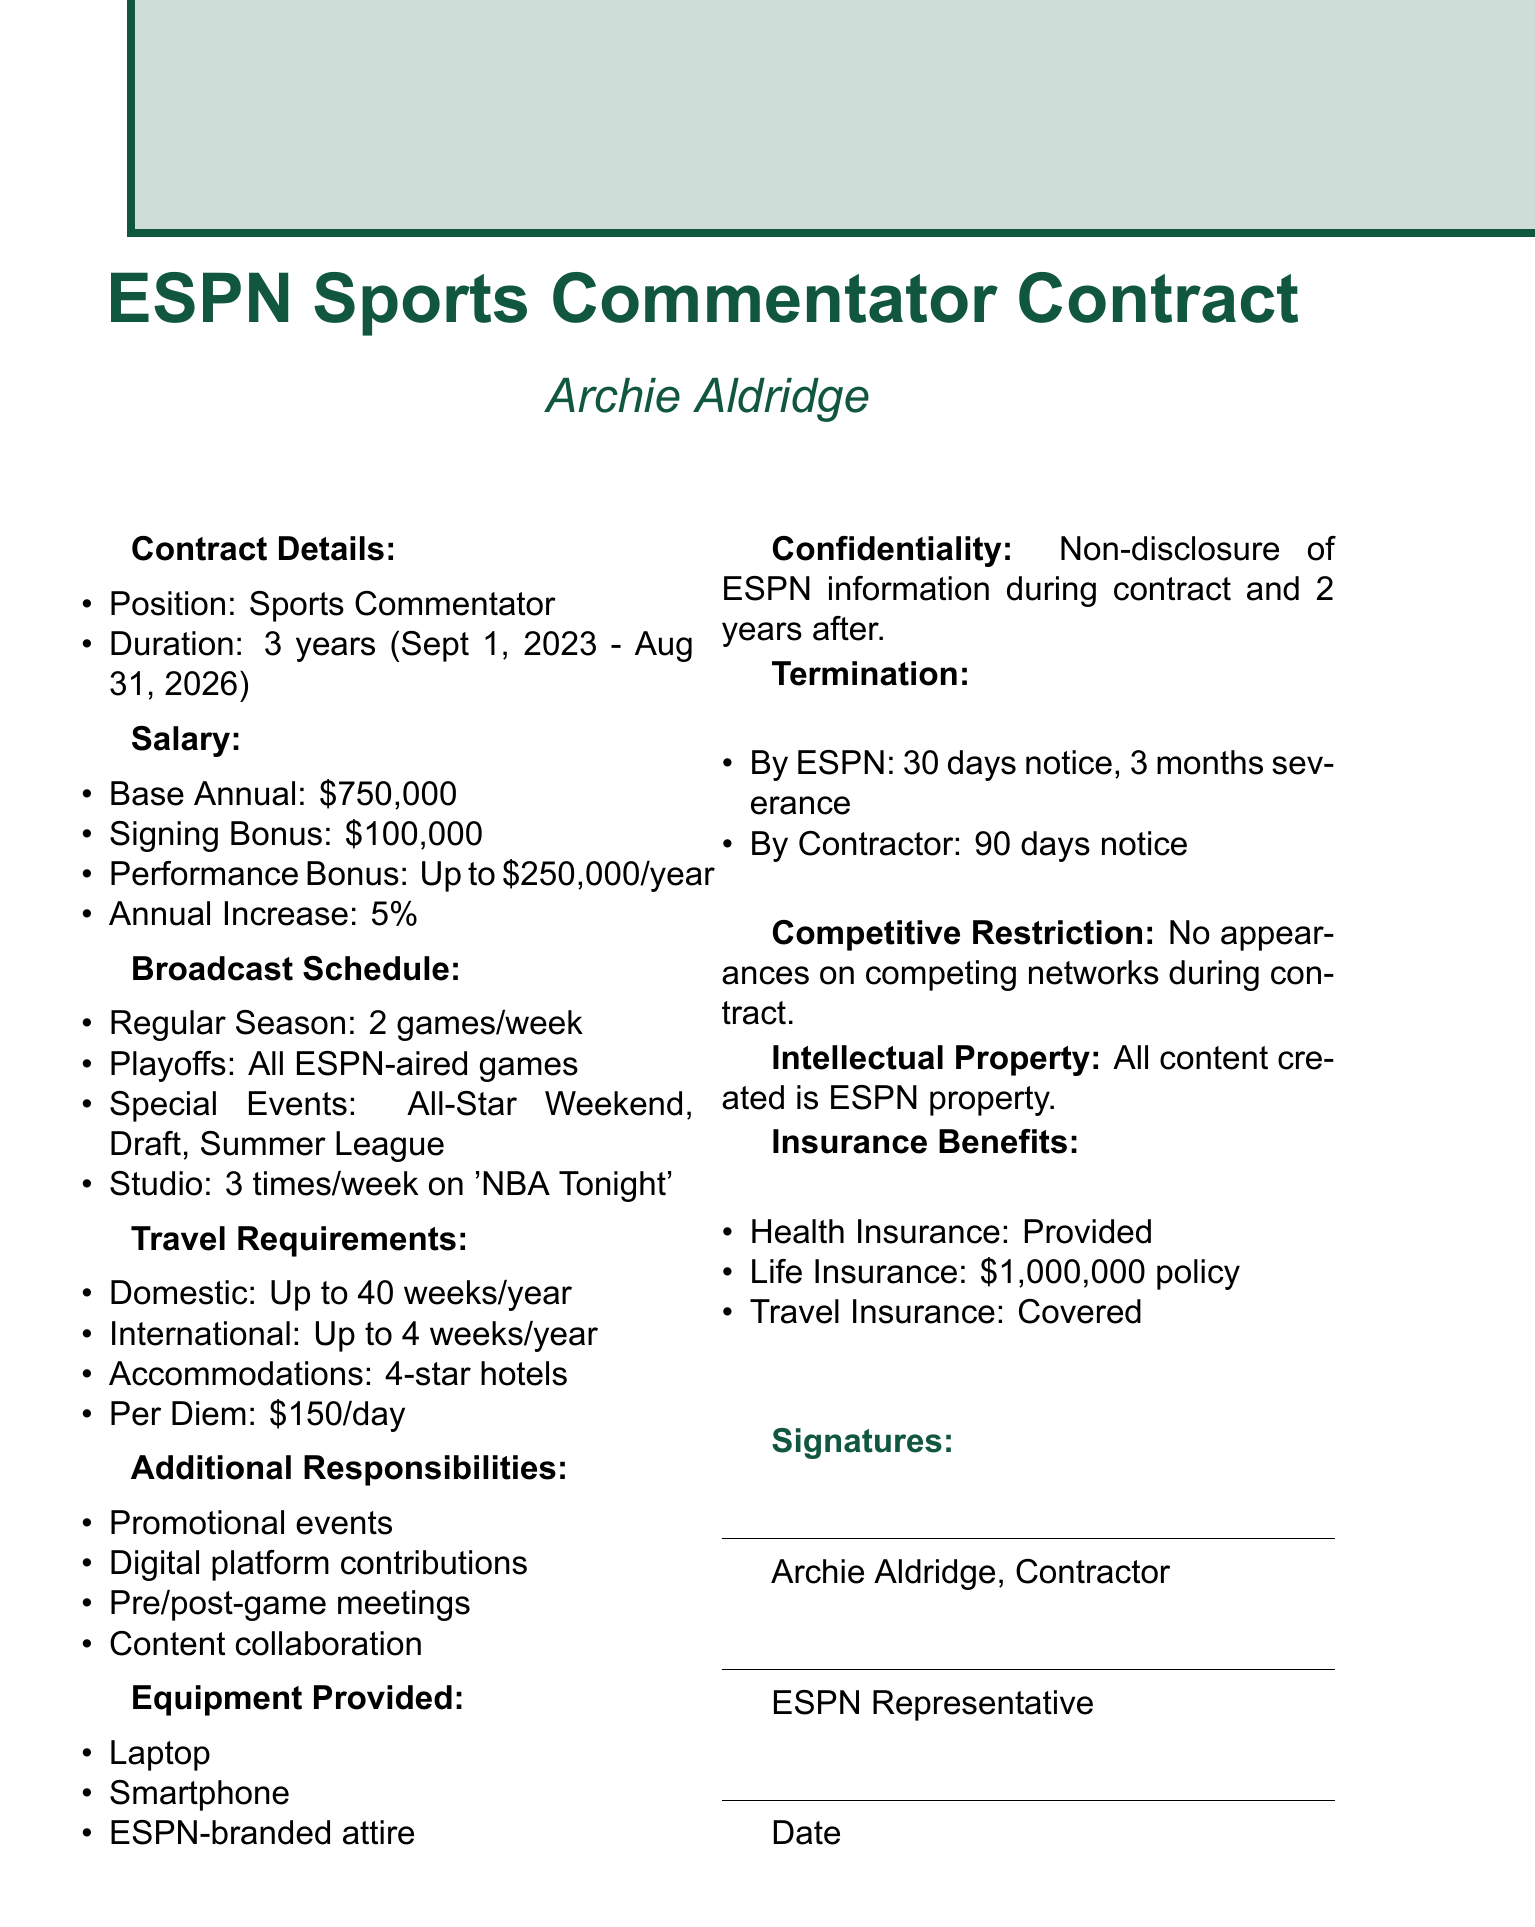What is the name of the television network? The network name is clearly stated in the document as the entity involved in the contract.
Answer: ESPN What is Archie Aldridge's annual base salary? The document specifies the annual base salary directly within the salary section.
Answer: $750,000 How long is the contract duration? The duration of the contract is explicitly mentioned in the contract details section.
Answer: 3 years How many regular season games will Archie commentate per week? The number of games per week is specified in the broadcast schedule of the document.
Answer: 2 games per week What is the maximum performance bonus per year? This detail is specified in the salary section and outlines potential earnings based on performance.
Answer: Up to $250,000 per year What is the per diem for travel? The per diem amount for meals and incidentals during travel is mentioned in the travel requirements.
Answer: $150 per day How much notice does ESPN need to give for termination? The termination clause provides specific notice periods required for termination by the network.
Answer: 30 days What is one of the additional responsibilities listed in the document? The additional responsibilities detail various expectations from the contractor within the document.
Answer: Participate in promotional events for ESPN Is there an insurance benefit provided? The document includes specifics about insurance benefits in the relevant section, indicating coverage.
Answer: Provided by ESPN 